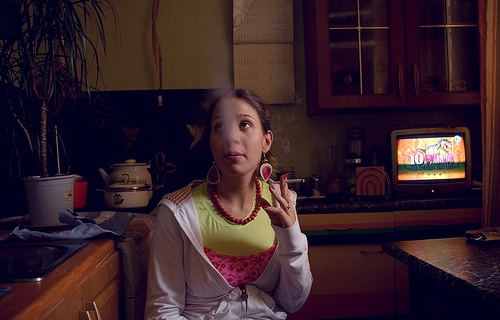Describe the objects in this image and their specific colors. I can see people in black, maroon, and gray tones, potted plant in black, maroon, and gray tones, dining table in black, maroon, and brown tones, tv in black, maroon, ivory, and khaki tones, and sink in black, maroon, and purple tones in this image. 